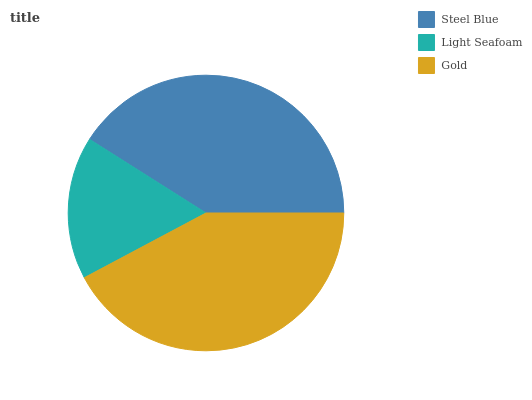Is Light Seafoam the minimum?
Answer yes or no. Yes. Is Gold the maximum?
Answer yes or no. Yes. Is Gold the minimum?
Answer yes or no. No. Is Light Seafoam the maximum?
Answer yes or no. No. Is Gold greater than Light Seafoam?
Answer yes or no. Yes. Is Light Seafoam less than Gold?
Answer yes or no. Yes. Is Light Seafoam greater than Gold?
Answer yes or no. No. Is Gold less than Light Seafoam?
Answer yes or no. No. Is Steel Blue the high median?
Answer yes or no. Yes. Is Steel Blue the low median?
Answer yes or no. Yes. Is Light Seafoam the high median?
Answer yes or no. No. Is Gold the low median?
Answer yes or no. No. 